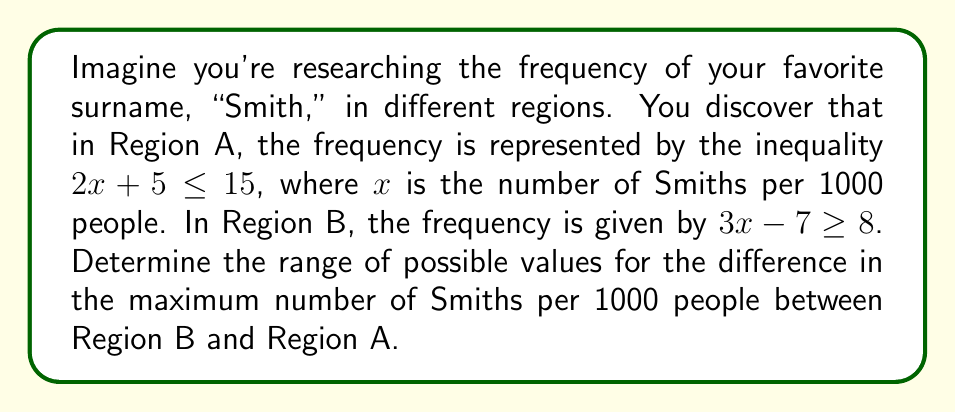Solve this math problem. Let's approach this step-by-step:

1) For Region A: $2x + 5 \leq 15$
   Subtracting 5 from both sides: $2x \leq 10$
   Dividing by 2: $x \leq 5$
   So, the maximum number of Smiths per 1000 people in Region A is 5.

2) For Region B: $3x - 7 \geq 8$
   Adding 7 to both sides: $3x \geq 15$
   Dividing by 3: $x \geq 5$
   The minimum number of Smiths per 1000 people in Region B is 5.

3) To find the maximum number in Region B, we need to consider that there can't be more than 1000 Smiths per 1000 people. So:
   $5 \leq x \leq 1000$

4) The difference in the maximum number of Smiths between Region B and Region A is:
   Maximum in B - Maximum in A = $1000 - 5 = 995$

5) The minimum difference would occur when Region B has its minimum value (5):
   Minimum in B - Maximum in A = $5 - 5 = 0$

Therefore, the range of possible values for the difference is $[0, 995]$.
Answer: $[0, 995]$ 